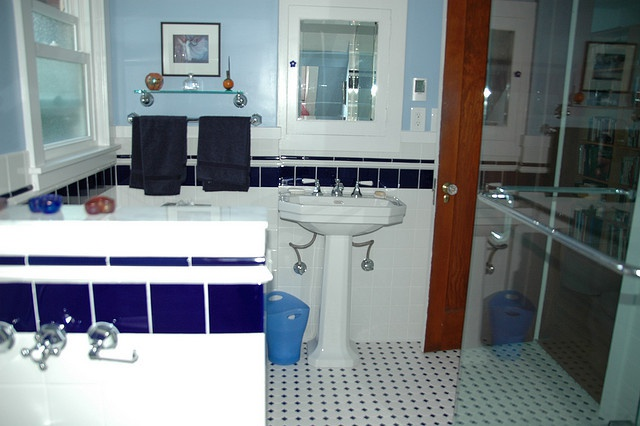Describe the objects in this image and their specific colors. I can see a sink in gray, darkgray, and lightgray tones in this image. 